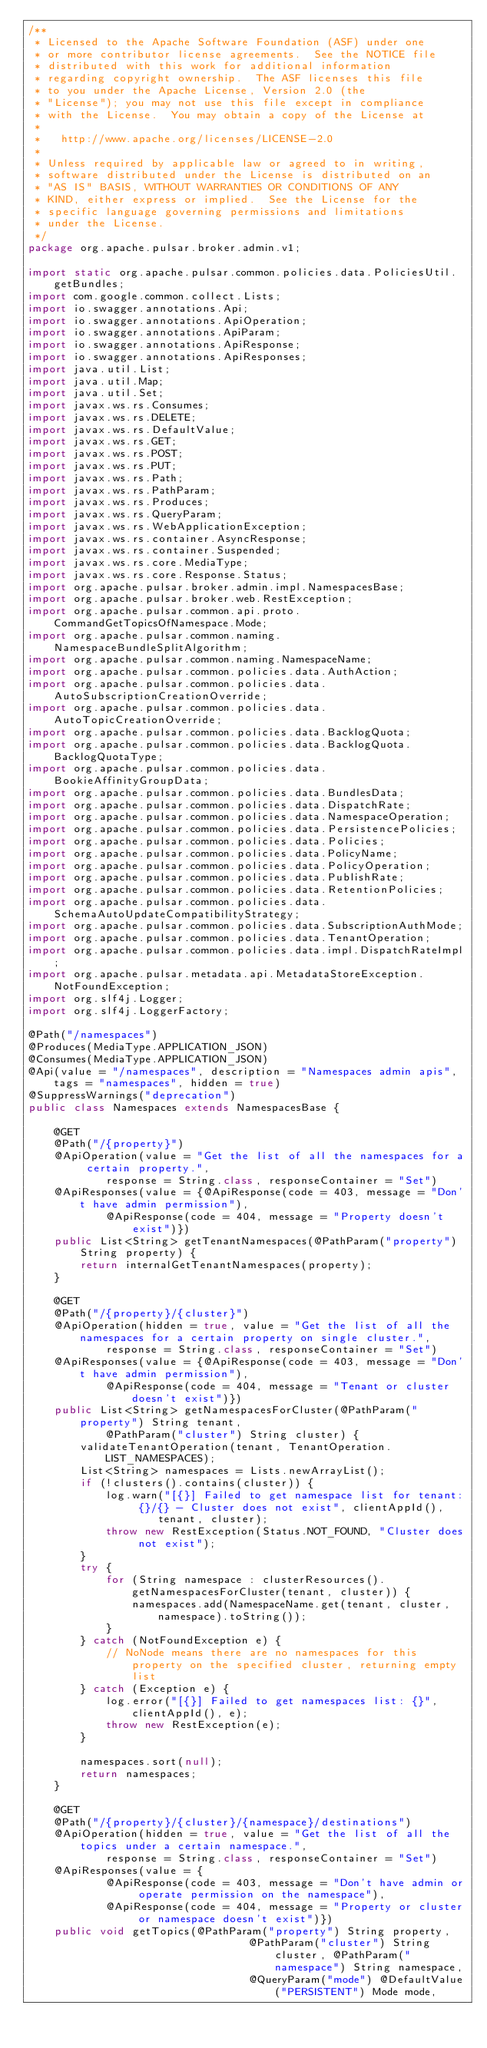Convert code to text. <code><loc_0><loc_0><loc_500><loc_500><_Java_>/**
 * Licensed to the Apache Software Foundation (ASF) under one
 * or more contributor license agreements.  See the NOTICE file
 * distributed with this work for additional information
 * regarding copyright ownership.  The ASF licenses this file
 * to you under the Apache License, Version 2.0 (the
 * "License"); you may not use this file except in compliance
 * with the License.  You may obtain a copy of the License at
 *
 *   http://www.apache.org/licenses/LICENSE-2.0
 *
 * Unless required by applicable law or agreed to in writing,
 * software distributed under the License is distributed on an
 * "AS IS" BASIS, WITHOUT WARRANTIES OR CONDITIONS OF ANY
 * KIND, either express or implied.  See the License for the
 * specific language governing permissions and limitations
 * under the License.
 */
package org.apache.pulsar.broker.admin.v1;

import static org.apache.pulsar.common.policies.data.PoliciesUtil.getBundles;
import com.google.common.collect.Lists;
import io.swagger.annotations.Api;
import io.swagger.annotations.ApiOperation;
import io.swagger.annotations.ApiParam;
import io.swagger.annotations.ApiResponse;
import io.swagger.annotations.ApiResponses;
import java.util.List;
import java.util.Map;
import java.util.Set;
import javax.ws.rs.Consumes;
import javax.ws.rs.DELETE;
import javax.ws.rs.DefaultValue;
import javax.ws.rs.GET;
import javax.ws.rs.POST;
import javax.ws.rs.PUT;
import javax.ws.rs.Path;
import javax.ws.rs.PathParam;
import javax.ws.rs.Produces;
import javax.ws.rs.QueryParam;
import javax.ws.rs.WebApplicationException;
import javax.ws.rs.container.AsyncResponse;
import javax.ws.rs.container.Suspended;
import javax.ws.rs.core.MediaType;
import javax.ws.rs.core.Response.Status;
import org.apache.pulsar.broker.admin.impl.NamespacesBase;
import org.apache.pulsar.broker.web.RestException;
import org.apache.pulsar.common.api.proto.CommandGetTopicsOfNamespace.Mode;
import org.apache.pulsar.common.naming.NamespaceBundleSplitAlgorithm;
import org.apache.pulsar.common.naming.NamespaceName;
import org.apache.pulsar.common.policies.data.AuthAction;
import org.apache.pulsar.common.policies.data.AutoSubscriptionCreationOverride;
import org.apache.pulsar.common.policies.data.AutoTopicCreationOverride;
import org.apache.pulsar.common.policies.data.BacklogQuota;
import org.apache.pulsar.common.policies.data.BacklogQuota.BacklogQuotaType;
import org.apache.pulsar.common.policies.data.BookieAffinityGroupData;
import org.apache.pulsar.common.policies.data.BundlesData;
import org.apache.pulsar.common.policies.data.DispatchRate;
import org.apache.pulsar.common.policies.data.NamespaceOperation;
import org.apache.pulsar.common.policies.data.PersistencePolicies;
import org.apache.pulsar.common.policies.data.Policies;
import org.apache.pulsar.common.policies.data.PolicyName;
import org.apache.pulsar.common.policies.data.PolicyOperation;
import org.apache.pulsar.common.policies.data.PublishRate;
import org.apache.pulsar.common.policies.data.RetentionPolicies;
import org.apache.pulsar.common.policies.data.SchemaAutoUpdateCompatibilityStrategy;
import org.apache.pulsar.common.policies.data.SubscriptionAuthMode;
import org.apache.pulsar.common.policies.data.TenantOperation;
import org.apache.pulsar.common.policies.data.impl.DispatchRateImpl;
import org.apache.pulsar.metadata.api.MetadataStoreException.NotFoundException;
import org.slf4j.Logger;
import org.slf4j.LoggerFactory;

@Path("/namespaces")
@Produces(MediaType.APPLICATION_JSON)
@Consumes(MediaType.APPLICATION_JSON)
@Api(value = "/namespaces", description = "Namespaces admin apis", tags = "namespaces", hidden = true)
@SuppressWarnings("deprecation")
public class Namespaces extends NamespacesBase {

    @GET
    @Path("/{property}")
    @ApiOperation(value = "Get the list of all the namespaces for a certain property.",
            response = String.class, responseContainer = "Set")
    @ApiResponses(value = {@ApiResponse(code = 403, message = "Don't have admin permission"),
            @ApiResponse(code = 404, message = "Property doesn't exist")})
    public List<String> getTenantNamespaces(@PathParam("property") String property) {
        return internalGetTenantNamespaces(property);
    }

    @GET
    @Path("/{property}/{cluster}")
    @ApiOperation(hidden = true, value = "Get the list of all the namespaces for a certain property on single cluster.",
            response = String.class, responseContainer = "Set")
    @ApiResponses(value = {@ApiResponse(code = 403, message = "Don't have admin permission"),
            @ApiResponse(code = 404, message = "Tenant or cluster doesn't exist")})
    public List<String> getNamespacesForCluster(@PathParam("property") String tenant,
            @PathParam("cluster") String cluster) {
        validateTenantOperation(tenant, TenantOperation.LIST_NAMESPACES);
        List<String> namespaces = Lists.newArrayList();
        if (!clusters().contains(cluster)) {
            log.warn("[{}] Failed to get namespace list for tenant: {}/{} - Cluster does not exist", clientAppId(),
                    tenant, cluster);
            throw new RestException(Status.NOT_FOUND, "Cluster does not exist");
        }
        try {
            for (String namespace : clusterResources().getNamespacesForCluster(tenant, cluster)) {
                namespaces.add(NamespaceName.get(tenant, cluster, namespace).toString());
            }
        } catch (NotFoundException e) {
            // NoNode means there are no namespaces for this property on the specified cluster, returning empty list
        } catch (Exception e) {
            log.error("[{}] Failed to get namespaces list: {}", clientAppId(), e);
            throw new RestException(e);
        }

        namespaces.sort(null);
        return namespaces;
    }

    @GET
    @Path("/{property}/{cluster}/{namespace}/destinations")
    @ApiOperation(hidden = true, value = "Get the list of all the topics under a certain namespace.",
            response = String.class, responseContainer = "Set")
    @ApiResponses(value = {
            @ApiResponse(code = 403, message = "Don't have admin or operate permission on the namespace"),
            @ApiResponse(code = 404, message = "Property or cluster or namespace doesn't exist")})
    public void getTopics(@PathParam("property") String property,
                                  @PathParam("cluster") String cluster, @PathParam("namespace") String namespace,
                                  @QueryParam("mode") @DefaultValue("PERSISTENT") Mode mode,</code> 